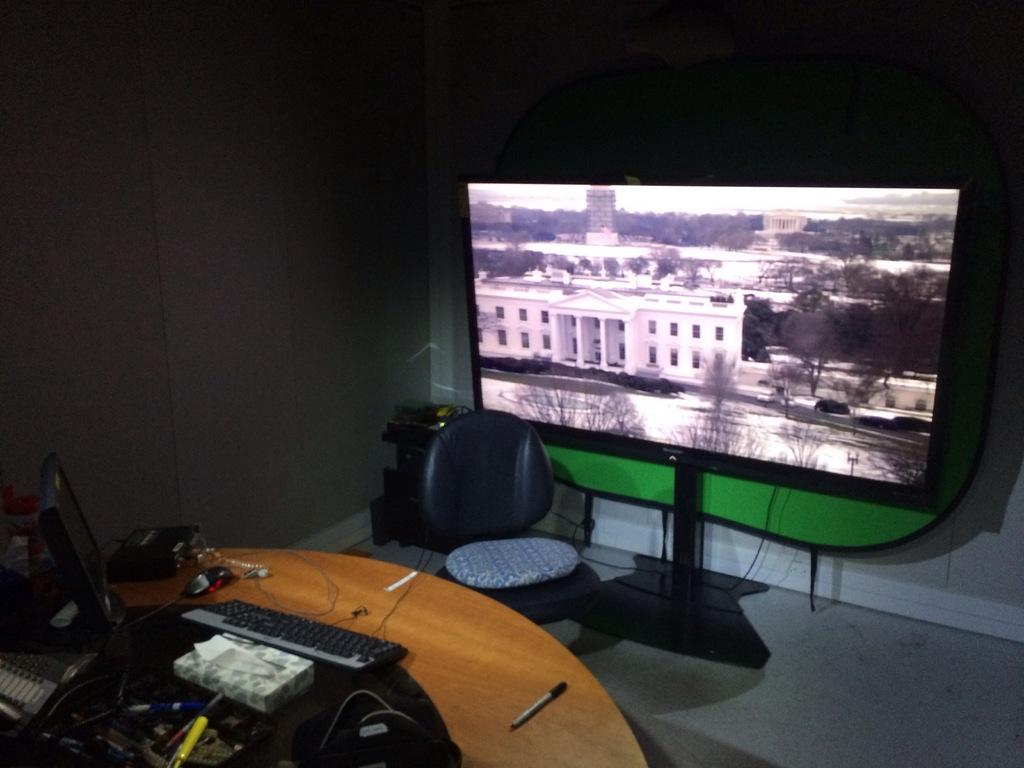What type of setting is depicted in the image? The image shows an inside view of a room. What can be seen on the table in the room? There is a monitor screen on a table, and there are other electronic items in front of the monitor screen. How many cacti are present on the table in the image? There are no cacti present on the table in the image. What grade does the monitor screen display in the image? The image does not show any information about the monitor screen's grade. 